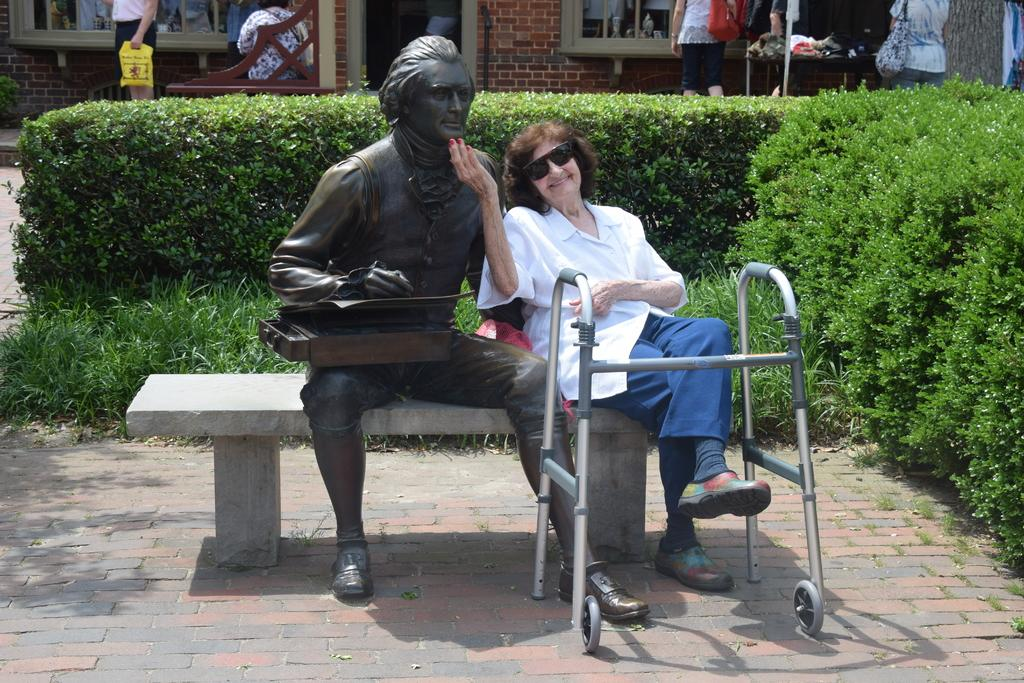What is the person in the image doing? There is a person sitting on a bench in the image. What is located next to the person? The person is sitting next to a statue. What type of vegetation is behind the person? There are plants behind the person. What can be seen in the distance in the image? There are buildings and windows visible in the background. How many sponges are being used by the person in the image? There are no sponges present in the image. What type of mass is being performed by the person in the image? The person is sitting on a bench, not performing any mass. 